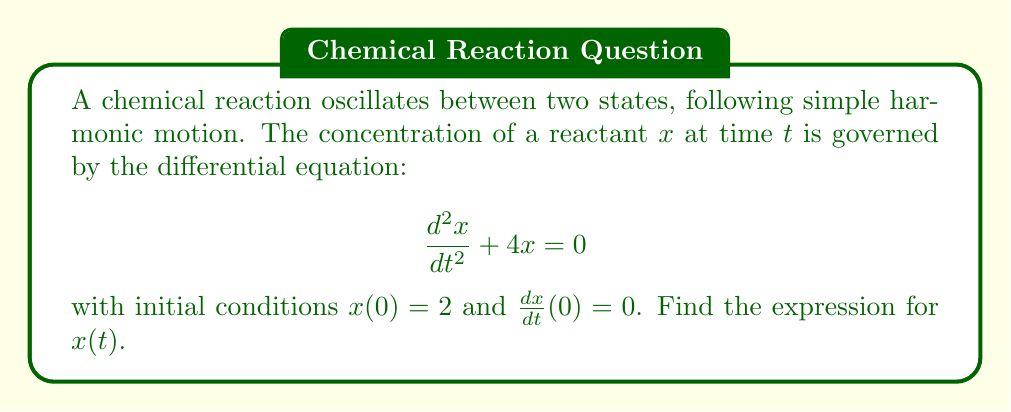Can you answer this question? 1) The given differential equation is in the form of a simple harmonic oscillator:
   $$\frac{d^2x}{dt^2} + \omega^2x = 0$$
   where $\omega^2 = 4$, so $\omega = 2$.

2) The general solution to this equation is:
   $$x(t) = A \cos(\omega t) + B \sin(\omega t)$$
   where $A$ and $B$ are constants determined by the initial conditions.

3) Substituting $\omega = 2$:
   $$x(t) = A \cos(2t) + B \sin(2t)$$

4) Using the first initial condition, $x(0) = 2$:
   $$2 = A \cos(0) + B \sin(0) = A$$

5) For the second initial condition, we need $\frac{dx}{dt}$:
   $$\frac{dx}{dt} = -2A \sin(2t) + 2B \cos(2t)$$

6) Using $\frac{dx}{dt}(0) = 0$:
   $$0 = -2A \sin(0) + 2B \cos(0) = 2B$$
   $$B = 0$$

7) Therefore, the solution is:
   $$x(t) = 2 \cos(2t)$$
Answer: $x(t) = 2 \cos(2t)$ 